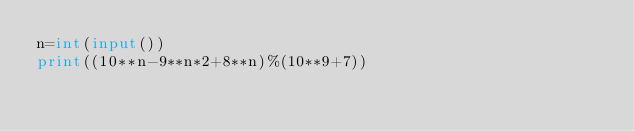<code> <loc_0><loc_0><loc_500><loc_500><_Python_>n=int(input())
print((10**n-9**n*2+8**n)%(10**9+7))</code> 